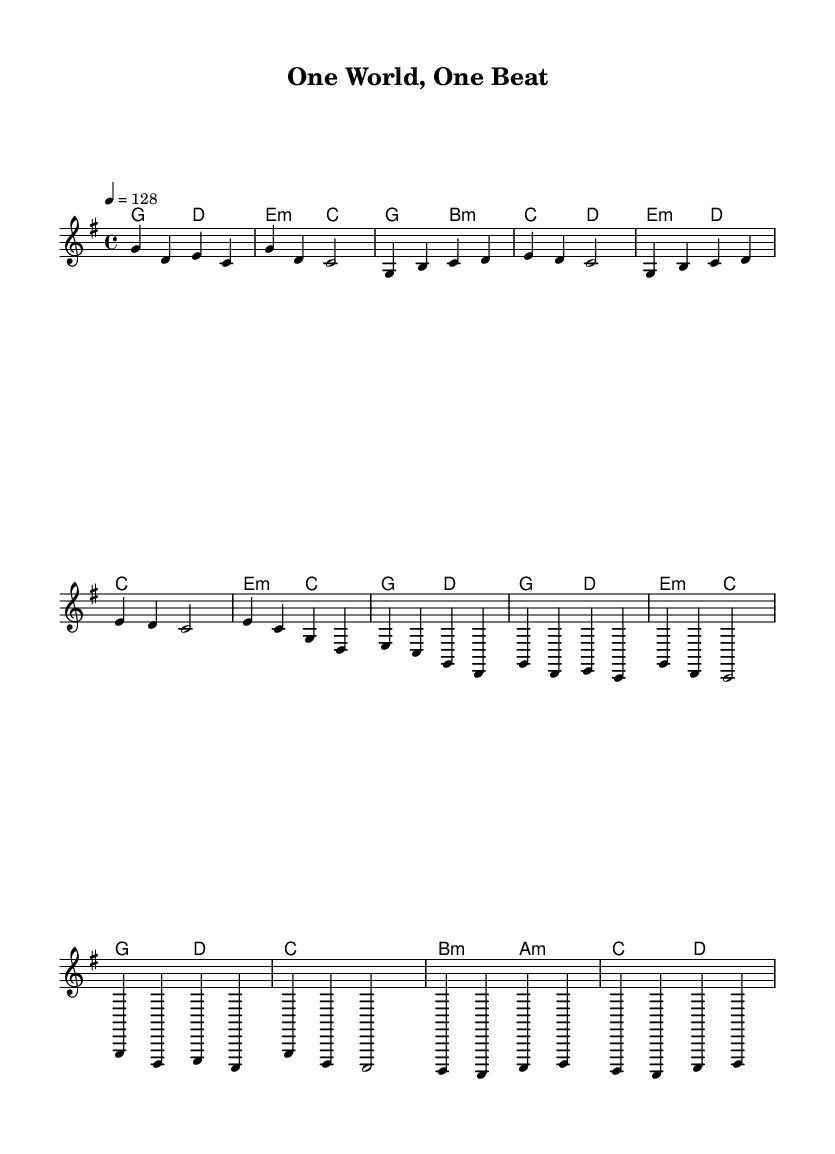What is the key signature of this music? The key signature indicated in the score shows one sharp, which identifies it as G major.
Answer: G major What is the time signature of this music? The time signature is shown as 4/4, which indicates four beats per measure.
Answer: 4/4 What is the tempo marking of this music? The tempo marking is set to "4 = 128," indicating a brisk tempo of 128 beats per minute.
Answer: 128 How many measures are in the verse section? The verse section consists of two repeated phrases, with each phrase containing four measures, resulting in a total of eight measures.
Answer: 8 What are the primary chords used in the chorus? The chorus prominently features the chords G, D, and E minor, which are essential in creating its harmonic foundation.
Answer: G, D, E minor Which musical section follows the pre-chorus? The section following the pre-chorus is labeled as the chorus, acting as a peak in the song's dynamic structure.
Answer: Chorus What musical concept does this piece exemplify by combining various world music influences? This piece embodies the concept of global unity and cooperation through its rhythmic and melodic elements that blend cultural influences.
Answer: Global unity 